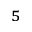<formula> <loc_0><loc_0><loc_500><loc_500>^ { 5 }</formula> 